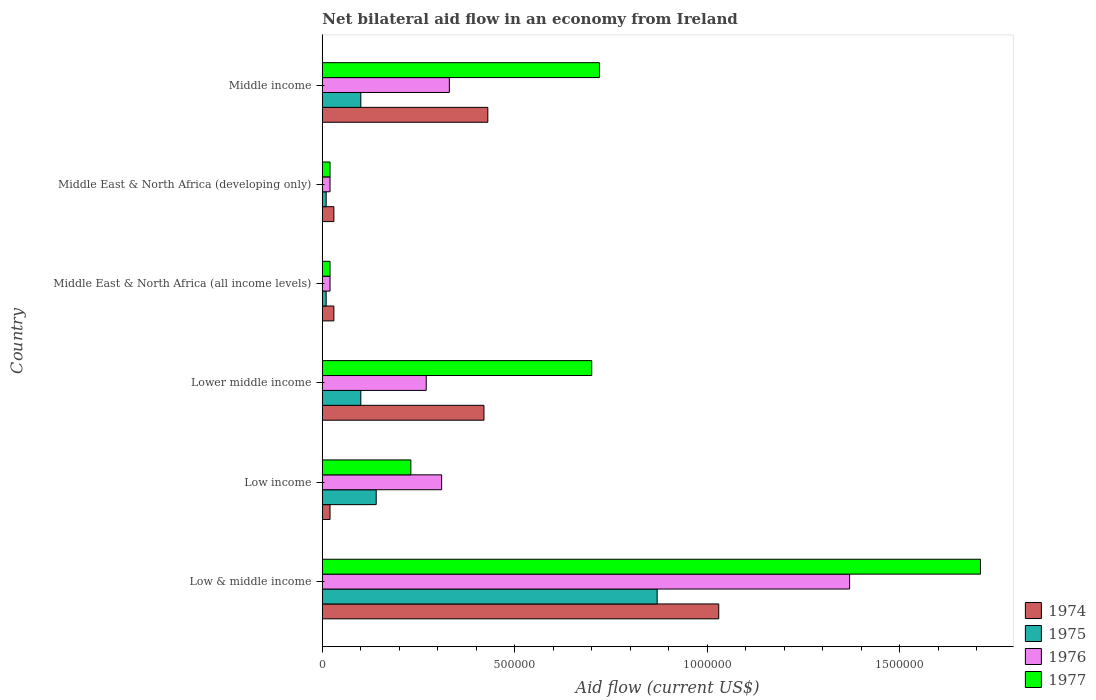How many groups of bars are there?
Offer a very short reply. 6. Are the number of bars on each tick of the Y-axis equal?
Keep it short and to the point. Yes. How many bars are there on the 2nd tick from the top?
Offer a very short reply. 4. How many bars are there on the 6th tick from the bottom?
Ensure brevity in your answer.  4. In how many cases, is the number of bars for a given country not equal to the number of legend labels?
Make the answer very short. 0. What is the net bilateral aid flow in 1977 in Middle East & North Africa (developing only)?
Your answer should be very brief. 2.00e+04. Across all countries, what is the maximum net bilateral aid flow in 1975?
Offer a very short reply. 8.70e+05. In which country was the net bilateral aid flow in 1976 minimum?
Ensure brevity in your answer.  Middle East & North Africa (all income levels). What is the total net bilateral aid flow in 1976 in the graph?
Keep it short and to the point. 2.32e+06. What is the difference between the net bilateral aid flow in 1977 in Low income and that in Middle income?
Your response must be concise. -4.90e+05. What is the difference between the net bilateral aid flow in 1977 in Middle East & North Africa (all income levels) and the net bilateral aid flow in 1975 in Low income?
Your response must be concise. -1.20e+05. What is the average net bilateral aid flow in 1974 per country?
Offer a very short reply. 3.27e+05. What is the difference between the net bilateral aid flow in 1976 and net bilateral aid flow in 1974 in Middle East & North Africa (developing only)?
Offer a very short reply. -10000. In how many countries, is the net bilateral aid flow in 1975 greater than 300000 US$?
Give a very brief answer. 1. What is the ratio of the net bilateral aid flow in 1974 in Lower middle income to that in Middle income?
Offer a very short reply. 0.98. Is the difference between the net bilateral aid flow in 1976 in Middle East & North Africa (all income levels) and Middle East & North Africa (developing only) greater than the difference between the net bilateral aid flow in 1974 in Middle East & North Africa (all income levels) and Middle East & North Africa (developing only)?
Offer a very short reply. No. What is the difference between the highest and the lowest net bilateral aid flow in 1975?
Offer a terse response. 8.60e+05. In how many countries, is the net bilateral aid flow in 1977 greater than the average net bilateral aid flow in 1977 taken over all countries?
Keep it short and to the point. 3. Is it the case that in every country, the sum of the net bilateral aid flow in 1975 and net bilateral aid flow in 1977 is greater than the sum of net bilateral aid flow in 1976 and net bilateral aid flow in 1974?
Give a very brief answer. No. What does the 1st bar from the top in Lower middle income represents?
Give a very brief answer. 1977. What does the 1st bar from the bottom in Low & middle income represents?
Provide a short and direct response. 1974. Is it the case that in every country, the sum of the net bilateral aid flow in 1976 and net bilateral aid flow in 1974 is greater than the net bilateral aid flow in 1977?
Your answer should be very brief. No. How many bars are there?
Offer a very short reply. 24. Are all the bars in the graph horizontal?
Provide a succinct answer. Yes. Does the graph contain any zero values?
Your answer should be very brief. No. Does the graph contain grids?
Offer a terse response. No. How many legend labels are there?
Your answer should be very brief. 4. What is the title of the graph?
Your answer should be very brief. Net bilateral aid flow in an economy from Ireland. What is the label or title of the X-axis?
Your answer should be compact. Aid flow (current US$). What is the Aid flow (current US$) of 1974 in Low & middle income?
Offer a terse response. 1.03e+06. What is the Aid flow (current US$) of 1975 in Low & middle income?
Offer a terse response. 8.70e+05. What is the Aid flow (current US$) of 1976 in Low & middle income?
Your answer should be very brief. 1.37e+06. What is the Aid flow (current US$) of 1977 in Low & middle income?
Keep it short and to the point. 1.71e+06. What is the Aid flow (current US$) of 1976 in Low income?
Your response must be concise. 3.10e+05. What is the Aid flow (current US$) in 1974 in Lower middle income?
Give a very brief answer. 4.20e+05. What is the Aid flow (current US$) of 1975 in Lower middle income?
Your answer should be very brief. 1.00e+05. What is the Aid flow (current US$) in 1976 in Lower middle income?
Make the answer very short. 2.70e+05. What is the Aid flow (current US$) of 1977 in Lower middle income?
Your answer should be very brief. 7.00e+05. What is the Aid flow (current US$) in 1976 in Middle East & North Africa (all income levels)?
Offer a very short reply. 2.00e+04. What is the Aid flow (current US$) of 1977 in Middle East & North Africa (all income levels)?
Provide a succinct answer. 2.00e+04. What is the Aid flow (current US$) in 1976 in Middle income?
Your response must be concise. 3.30e+05. What is the Aid flow (current US$) of 1977 in Middle income?
Give a very brief answer. 7.20e+05. Across all countries, what is the maximum Aid flow (current US$) of 1974?
Your answer should be very brief. 1.03e+06. Across all countries, what is the maximum Aid flow (current US$) of 1975?
Provide a succinct answer. 8.70e+05. Across all countries, what is the maximum Aid flow (current US$) in 1976?
Your answer should be very brief. 1.37e+06. Across all countries, what is the maximum Aid flow (current US$) of 1977?
Provide a short and direct response. 1.71e+06. Across all countries, what is the minimum Aid flow (current US$) in 1974?
Your response must be concise. 2.00e+04. Across all countries, what is the minimum Aid flow (current US$) in 1976?
Make the answer very short. 2.00e+04. Across all countries, what is the minimum Aid flow (current US$) in 1977?
Provide a succinct answer. 2.00e+04. What is the total Aid flow (current US$) of 1974 in the graph?
Offer a very short reply. 1.96e+06. What is the total Aid flow (current US$) of 1975 in the graph?
Your answer should be compact. 1.23e+06. What is the total Aid flow (current US$) of 1976 in the graph?
Your answer should be very brief. 2.32e+06. What is the total Aid flow (current US$) of 1977 in the graph?
Your response must be concise. 3.40e+06. What is the difference between the Aid flow (current US$) of 1974 in Low & middle income and that in Low income?
Provide a short and direct response. 1.01e+06. What is the difference between the Aid flow (current US$) of 1975 in Low & middle income and that in Low income?
Provide a short and direct response. 7.30e+05. What is the difference between the Aid flow (current US$) in 1976 in Low & middle income and that in Low income?
Provide a short and direct response. 1.06e+06. What is the difference between the Aid flow (current US$) of 1977 in Low & middle income and that in Low income?
Give a very brief answer. 1.48e+06. What is the difference between the Aid flow (current US$) in 1974 in Low & middle income and that in Lower middle income?
Keep it short and to the point. 6.10e+05. What is the difference between the Aid flow (current US$) in 1975 in Low & middle income and that in Lower middle income?
Give a very brief answer. 7.70e+05. What is the difference between the Aid flow (current US$) in 1976 in Low & middle income and that in Lower middle income?
Provide a short and direct response. 1.10e+06. What is the difference between the Aid flow (current US$) of 1977 in Low & middle income and that in Lower middle income?
Your answer should be compact. 1.01e+06. What is the difference between the Aid flow (current US$) of 1974 in Low & middle income and that in Middle East & North Africa (all income levels)?
Give a very brief answer. 1.00e+06. What is the difference between the Aid flow (current US$) of 1975 in Low & middle income and that in Middle East & North Africa (all income levels)?
Provide a succinct answer. 8.60e+05. What is the difference between the Aid flow (current US$) in 1976 in Low & middle income and that in Middle East & North Africa (all income levels)?
Make the answer very short. 1.35e+06. What is the difference between the Aid flow (current US$) of 1977 in Low & middle income and that in Middle East & North Africa (all income levels)?
Your answer should be compact. 1.69e+06. What is the difference between the Aid flow (current US$) in 1975 in Low & middle income and that in Middle East & North Africa (developing only)?
Provide a succinct answer. 8.60e+05. What is the difference between the Aid flow (current US$) of 1976 in Low & middle income and that in Middle East & North Africa (developing only)?
Make the answer very short. 1.35e+06. What is the difference between the Aid flow (current US$) in 1977 in Low & middle income and that in Middle East & North Africa (developing only)?
Your answer should be compact. 1.69e+06. What is the difference between the Aid flow (current US$) of 1975 in Low & middle income and that in Middle income?
Give a very brief answer. 7.70e+05. What is the difference between the Aid flow (current US$) of 1976 in Low & middle income and that in Middle income?
Your answer should be very brief. 1.04e+06. What is the difference between the Aid flow (current US$) of 1977 in Low & middle income and that in Middle income?
Provide a succinct answer. 9.90e+05. What is the difference between the Aid flow (current US$) in 1974 in Low income and that in Lower middle income?
Your answer should be very brief. -4.00e+05. What is the difference between the Aid flow (current US$) in 1977 in Low income and that in Lower middle income?
Ensure brevity in your answer.  -4.70e+05. What is the difference between the Aid flow (current US$) of 1974 in Low income and that in Middle East & North Africa (all income levels)?
Your answer should be very brief. -10000. What is the difference between the Aid flow (current US$) in 1975 in Low income and that in Middle East & North Africa (all income levels)?
Ensure brevity in your answer.  1.30e+05. What is the difference between the Aid flow (current US$) of 1976 in Low income and that in Middle East & North Africa (developing only)?
Your response must be concise. 2.90e+05. What is the difference between the Aid flow (current US$) of 1977 in Low income and that in Middle East & North Africa (developing only)?
Make the answer very short. 2.10e+05. What is the difference between the Aid flow (current US$) of 1974 in Low income and that in Middle income?
Give a very brief answer. -4.10e+05. What is the difference between the Aid flow (current US$) of 1977 in Low income and that in Middle income?
Your answer should be very brief. -4.90e+05. What is the difference between the Aid flow (current US$) of 1974 in Lower middle income and that in Middle East & North Africa (all income levels)?
Provide a short and direct response. 3.90e+05. What is the difference between the Aid flow (current US$) in 1975 in Lower middle income and that in Middle East & North Africa (all income levels)?
Your answer should be very brief. 9.00e+04. What is the difference between the Aid flow (current US$) in 1977 in Lower middle income and that in Middle East & North Africa (all income levels)?
Keep it short and to the point. 6.80e+05. What is the difference between the Aid flow (current US$) in 1974 in Lower middle income and that in Middle East & North Africa (developing only)?
Offer a very short reply. 3.90e+05. What is the difference between the Aid flow (current US$) of 1975 in Lower middle income and that in Middle East & North Africa (developing only)?
Provide a short and direct response. 9.00e+04. What is the difference between the Aid flow (current US$) of 1977 in Lower middle income and that in Middle East & North Africa (developing only)?
Ensure brevity in your answer.  6.80e+05. What is the difference between the Aid flow (current US$) in 1975 in Lower middle income and that in Middle income?
Give a very brief answer. 0. What is the difference between the Aid flow (current US$) in 1976 in Lower middle income and that in Middle income?
Offer a very short reply. -6.00e+04. What is the difference between the Aid flow (current US$) of 1977 in Lower middle income and that in Middle income?
Your answer should be very brief. -2.00e+04. What is the difference between the Aid flow (current US$) of 1974 in Middle East & North Africa (all income levels) and that in Middle East & North Africa (developing only)?
Your response must be concise. 0. What is the difference between the Aid flow (current US$) of 1976 in Middle East & North Africa (all income levels) and that in Middle East & North Africa (developing only)?
Provide a succinct answer. 0. What is the difference between the Aid flow (current US$) of 1974 in Middle East & North Africa (all income levels) and that in Middle income?
Your answer should be very brief. -4.00e+05. What is the difference between the Aid flow (current US$) in 1976 in Middle East & North Africa (all income levels) and that in Middle income?
Offer a terse response. -3.10e+05. What is the difference between the Aid flow (current US$) of 1977 in Middle East & North Africa (all income levels) and that in Middle income?
Make the answer very short. -7.00e+05. What is the difference between the Aid flow (current US$) in 1974 in Middle East & North Africa (developing only) and that in Middle income?
Ensure brevity in your answer.  -4.00e+05. What is the difference between the Aid flow (current US$) in 1976 in Middle East & North Africa (developing only) and that in Middle income?
Provide a succinct answer. -3.10e+05. What is the difference between the Aid flow (current US$) of 1977 in Middle East & North Africa (developing only) and that in Middle income?
Your answer should be compact. -7.00e+05. What is the difference between the Aid flow (current US$) of 1974 in Low & middle income and the Aid flow (current US$) of 1975 in Low income?
Provide a short and direct response. 8.90e+05. What is the difference between the Aid flow (current US$) in 1974 in Low & middle income and the Aid flow (current US$) in 1976 in Low income?
Keep it short and to the point. 7.20e+05. What is the difference between the Aid flow (current US$) of 1975 in Low & middle income and the Aid flow (current US$) of 1976 in Low income?
Offer a terse response. 5.60e+05. What is the difference between the Aid flow (current US$) in 1975 in Low & middle income and the Aid flow (current US$) in 1977 in Low income?
Provide a short and direct response. 6.40e+05. What is the difference between the Aid flow (current US$) in 1976 in Low & middle income and the Aid flow (current US$) in 1977 in Low income?
Keep it short and to the point. 1.14e+06. What is the difference between the Aid flow (current US$) of 1974 in Low & middle income and the Aid flow (current US$) of 1975 in Lower middle income?
Give a very brief answer. 9.30e+05. What is the difference between the Aid flow (current US$) of 1974 in Low & middle income and the Aid flow (current US$) of 1976 in Lower middle income?
Give a very brief answer. 7.60e+05. What is the difference between the Aid flow (current US$) in 1976 in Low & middle income and the Aid flow (current US$) in 1977 in Lower middle income?
Make the answer very short. 6.70e+05. What is the difference between the Aid flow (current US$) of 1974 in Low & middle income and the Aid flow (current US$) of 1975 in Middle East & North Africa (all income levels)?
Provide a short and direct response. 1.02e+06. What is the difference between the Aid flow (current US$) in 1974 in Low & middle income and the Aid flow (current US$) in 1976 in Middle East & North Africa (all income levels)?
Provide a succinct answer. 1.01e+06. What is the difference between the Aid flow (current US$) in 1974 in Low & middle income and the Aid flow (current US$) in 1977 in Middle East & North Africa (all income levels)?
Your answer should be very brief. 1.01e+06. What is the difference between the Aid flow (current US$) in 1975 in Low & middle income and the Aid flow (current US$) in 1976 in Middle East & North Africa (all income levels)?
Keep it short and to the point. 8.50e+05. What is the difference between the Aid flow (current US$) of 1975 in Low & middle income and the Aid flow (current US$) of 1977 in Middle East & North Africa (all income levels)?
Make the answer very short. 8.50e+05. What is the difference between the Aid flow (current US$) of 1976 in Low & middle income and the Aid flow (current US$) of 1977 in Middle East & North Africa (all income levels)?
Keep it short and to the point. 1.35e+06. What is the difference between the Aid flow (current US$) of 1974 in Low & middle income and the Aid flow (current US$) of 1975 in Middle East & North Africa (developing only)?
Provide a succinct answer. 1.02e+06. What is the difference between the Aid flow (current US$) in 1974 in Low & middle income and the Aid flow (current US$) in 1976 in Middle East & North Africa (developing only)?
Offer a terse response. 1.01e+06. What is the difference between the Aid flow (current US$) of 1974 in Low & middle income and the Aid flow (current US$) of 1977 in Middle East & North Africa (developing only)?
Keep it short and to the point. 1.01e+06. What is the difference between the Aid flow (current US$) in 1975 in Low & middle income and the Aid flow (current US$) in 1976 in Middle East & North Africa (developing only)?
Make the answer very short. 8.50e+05. What is the difference between the Aid flow (current US$) in 1975 in Low & middle income and the Aid flow (current US$) in 1977 in Middle East & North Africa (developing only)?
Make the answer very short. 8.50e+05. What is the difference between the Aid flow (current US$) in 1976 in Low & middle income and the Aid flow (current US$) in 1977 in Middle East & North Africa (developing only)?
Keep it short and to the point. 1.35e+06. What is the difference between the Aid flow (current US$) in 1974 in Low & middle income and the Aid flow (current US$) in 1975 in Middle income?
Make the answer very short. 9.30e+05. What is the difference between the Aid flow (current US$) in 1975 in Low & middle income and the Aid flow (current US$) in 1976 in Middle income?
Ensure brevity in your answer.  5.40e+05. What is the difference between the Aid flow (current US$) in 1975 in Low & middle income and the Aid flow (current US$) in 1977 in Middle income?
Give a very brief answer. 1.50e+05. What is the difference between the Aid flow (current US$) in 1976 in Low & middle income and the Aid flow (current US$) in 1977 in Middle income?
Your response must be concise. 6.50e+05. What is the difference between the Aid flow (current US$) in 1974 in Low income and the Aid flow (current US$) in 1975 in Lower middle income?
Provide a succinct answer. -8.00e+04. What is the difference between the Aid flow (current US$) in 1974 in Low income and the Aid flow (current US$) in 1976 in Lower middle income?
Offer a terse response. -2.50e+05. What is the difference between the Aid flow (current US$) of 1974 in Low income and the Aid flow (current US$) of 1977 in Lower middle income?
Your answer should be compact. -6.80e+05. What is the difference between the Aid flow (current US$) in 1975 in Low income and the Aid flow (current US$) in 1977 in Lower middle income?
Keep it short and to the point. -5.60e+05. What is the difference between the Aid flow (current US$) in 1976 in Low income and the Aid flow (current US$) in 1977 in Lower middle income?
Provide a short and direct response. -3.90e+05. What is the difference between the Aid flow (current US$) of 1974 in Low income and the Aid flow (current US$) of 1975 in Middle East & North Africa (all income levels)?
Offer a terse response. 10000. What is the difference between the Aid flow (current US$) in 1974 in Low income and the Aid flow (current US$) in 1976 in Middle East & North Africa (all income levels)?
Provide a short and direct response. 0. What is the difference between the Aid flow (current US$) of 1974 in Low income and the Aid flow (current US$) of 1977 in Middle East & North Africa (all income levels)?
Provide a succinct answer. 0. What is the difference between the Aid flow (current US$) in 1974 in Low income and the Aid flow (current US$) in 1977 in Middle East & North Africa (developing only)?
Keep it short and to the point. 0. What is the difference between the Aid flow (current US$) of 1975 in Low income and the Aid flow (current US$) of 1976 in Middle East & North Africa (developing only)?
Keep it short and to the point. 1.20e+05. What is the difference between the Aid flow (current US$) of 1974 in Low income and the Aid flow (current US$) of 1975 in Middle income?
Provide a succinct answer. -8.00e+04. What is the difference between the Aid flow (current US$) in 1974 in Low income and the Aid flow (current US$) in 1976 in Middle income?
Offer a terse response. -3.10e+05. What is the difference between the Aid flow (current US$) in 1974 in Low income and the Aid flow (current US$) in 1977 in Middle income?
Ensure brevity in your answer.  -7.00e+05. What is the difference between the Aid flow (current US$) in 1975 in Low income and the Aid flow (current US$) in 1976 in Middle income?
Your response must be concise. -1.90e+05. What is the difference between the Aid flow (current US$) of 1975 in Low income and the Aid flow (current US$) of 1977 in Middle income?
Give a very brief answer. -5.80e+05. What is the difference between the Aid flow (current US$) in 1976 in Low income and the Aid flow (current US$) in 1977 in Middle income?
Offer a very short reply. -4.10e+05. What is the difference between the Aid flow (current US$) of 1975 in Lower middle income and the Aid flow (current US$) of 1976 in Middle East & North Africa (all income levels)?
Your response must be concise. 8.00e+04. What is the difference between the Aid flow (current US$) of 1976 in Lower middle income and the Aid flow (current US$) of 1977 in Middle East & North Africa (all income levels)?
Your answer should be very brief. 2.50e+05. What is the difference between the Aid flow (current US$) of 1974 in Lower middle income and the Aid flow (current US$) of 1977 in Middle East & North Africa (developing only)?
Your response must be concise. 4.00e+05. What is the difference between the Aid flow (current US$) of 1974 in Lower middle income and the Aid flow (current US$) of 1975 in Middle income?
Ensure brevity in your answer.  3.20e+05. What is the difference between the Aid flow (current US$) in 1974 in Lower middle income and the Aid flow (current US$) in 1976 in Middle income?
Provide a succinct answer. 9.00e+04. What is the difference between the Aid flow (current US$) of 1974 in Lower middle income and the Aid flow (current US$) of 1977 in Middle income?
Provide a succinct answer. -3.00e+05. What is the difference between the Aid flow (current US$) of 1975 in Lower middle income and the Aid flow (current US$) of 1976 in Middle income?
Offer a terse response. -2.30e+05. What is the difference between the Aid flow (current US$) in 1975 in Lower middle income and the Aid flow (current US$) in 1977 in Middle income?
Give a very brief answer. -6.20e+05. What is the difference between the Aid flow (current US$) in 1976 in Lower middle income and the Aid flow (current US$) in 1977 in Middle income?
Offer a terse response. -4.50e+05. What is the difference between the Aid flow (current US$) of 1974 in Middle East & North Africa (all income levels) and the Aid flow (current US$) of 1975 in Middle East & North Africa (developing only)?
Your answer should be compact. 2.00e+04. What is the difference between the Aid flow (current US$) of 1974 in Middle East & North Africa (all income levels) and the Aid flow (current US$) of 1976 in Middle East & North Africa (developing only)?
Provide a succinct answer. 10000. What is the difference between the Aid flow (current US$) in 1975 in Middle East & North Africa (all income levels) and the Aid flow (current US$) in 1977 in Middle East & North Africa (developing only)?
Offer a very short reply. -10000. What is the difference between the Aid flow (current US$) of 1974 in Middle East & North Africa (all income levels) and the Aid flow (current US$) of 1977 in Middle income?
Your answer should be very brief. -6.90e+05. What is the difference between the Aid flow (current US$) of 1975 in Middle East & North Africa (all income levels) and the Aid flow (current US$) of 1976 in Middle income?
Give a very brief answer. -3.20e+05. What is the difference between the Aid flow (current US$) of 1975 in Middle East & North Africa (all income levels) and the Aid flow (current US$) of 1977 in Middle income?
Provide a succinct answer. -7.10e+05. What is the difference between the Aid flow (current US$) of 1976 in Middle East & North Africa (all income levels) and the Aid flow (current US$) of 1977 in Middle income?
Provide a succinct answer. -7.00e+05. What is the difference between the Aid flow (current US$) in 1974 in Middle East & North Africa (developing only) and the Aid flow (current US$) in 1976 in Middle income?
Provide a short and direct response. -3.00e+05. What is the difference between the Aid flow (current US$) in 1974 in Middle East & North Africa (developing only) and the Aid flow (current US$) in 1977 in Middle income?
Give a very brief answer. -6.90e+05. What is the difference between the Aid flow (current US$) of 1975 in Middle East & North Africa (developing only) and the Aid flow (current US$) of 1976 in Middle income?
Keep it short and to the point. -3.20e+05. What is the difference between the Aid flow (current US$) of 1975 in Middle East & North Africa (developing only) and the Aid flow (current US$) of 1977 in Middle income?
Your answer should be very brief. -7.10e+05. What is the difference between the Aid flow (current US$) in 1976 in Middle East & North Africa (developing only) and the Aid flow (current US$) in 1977 in Middle income?
Give a very brief answer. -7.00e+05. What is the average Aid flow (current US$) in 1974 per country?
Give a very brief answer. 3.27e+05. What is the average Aid flow (current US$) in 1975 per country?
Make the answer very short. 2.05e+05. What is the average Aid flow (current US$) in 1976 per country?
Provide a short and direct response. 3.87e+05. What is the average Aid flow (current US$) of 1977 per country?
Provide a succinct answer. 5.67e+05. What is the difference between the Aid flow (current US$) in 1974 and Aid flow (current US$) in 1977 in Low & middle income?
Your answer should be compact. -6.80e+05. What is the difference between the Aid flow (current US$) in 1975 and Aid flow (current US$) in 1976 in Low & middle income?
Your response must be concise. -5.00e+05. What is the difference between the Aid flow (current US$) in 1975 and Aid flow (current US$) in 1977 in Low & middle income?
Offer a very short reply. -8.40e+05. What is the difference between the Aid flow (current US$) in 1975 and Aid flow (current US$) in 1977 in Low income?
Keep it short and to the point. -9.00e+04. What is the difference between the Aid flow (current US$) of 1974 and Aid flow (current US$) of 1975 in Lower middle income?
Keep it short and to the point. 3.20e+05. What is the difference between the Aid flow (current US$) of 1974 and Aid flow (current US$) of 1977 in Lower middle income?
Provide a short and direct response. -2.80e+05. What is the difference between the Aid flow (current US$) in 1975 and Aid flow (current US$) in 1977 in Lower middle income?
Offer a very short reply. -6.00e+05. What is the difference between the Aid flow (current US$) of 1976 and Aid flow (current US$) of 1977 in Lower middle income?
Offer a terse response. -4.30e+05. What is the difference between the Aid flow (current US$) in 1974 and Aid flow (current US$) in 1977 in Middle East & North Africa (all income levels)?
Make the answer very short. 10000. What is the difference between the Aid flow (current US$) of 1975 and Aid flow (current US$) of 1976 in Middle East & North Africa (all income levels)?
Ensure brevity in your answer.  -10000. What is the difference between the Aid flow (current US$) in 1974 and Aid flow (current US$) in 1975 in Middle East & North Africa (developing only)?
Give a very brief answer. 2.00e+04. What is the difference between the Aid flow (current US$) of 1974 and Aid flow (current US$) of 1976 in Middle East & North Africa (developing only)?
Ensure brevity in your answer.  10000. What is the difference between the Aid flow (current US$) of 1974 and Aid flow (current US$) of 1977 in Middle East & North Africa (developing only)?
Your response must be concise. 10000. What is the difference between the Aid flow (current US$) of 1975 and Aid flow (current US$) of 1976 in Middle East & North Africa (developing only)?
Make the answer very short. -10000. What is the difference between the Aid flow (current US$) of 1975 and Aid flow (current US$) of 1977 in Middle East & North Africa (developing only)?
Give a very brief answer. -10000. What is the difference between the Aid flow (current US$) in 1974 and Aid flow (current US$) in 1975 in Middle income?
Provide a short and direct response. 3.30e+05. What is the difference between the Aid flow (current US$) in 1975 and Aid flow (current US$) in 1977 in Middle income?
Offer a very short reply. -6.20e+05. What is the difference between the Aid flow (current US$) of 1976 and Aid flow (current US$) of 1977 in Middle income?
Ensure brevity in your answer.  -3.90e+05. What is the ratio of the Aid flow (current US$) in 1974 in Low & middle income to that in Low income?
Keep it short and to the point. 51.5. What is the ratio of the Aid flow (current US$) of 1975 in Low & middle income to that in Low income?
Offer a terse response. 6.21. What is the ratio of the Aid flow (current US$) in 1976 in Low & middle income to that in Low income?
Make the answer very short. 4.42. What is the ratio of the Aid flow (current US$) of 1977 in Low & middle income to that in Low income?
Offer a terse response. 7.43. What is the ratio of the Aid flow (current US$) in 1974 in Low & middle income to that in Lower middle income?
Make the answer very short. 2.45. What is the ratio of the Aid flow (current US$) of 1975 in Low & middle income to that in Lower middle income?
Provide a short and direct response. 8.7. What is the ratio of the Aid flow (current US$) in 1976 in Low & middle income to that in Lower middle income?
Your answer should be very brief. 5.07. What is the ratio of the Aid flow (current US$) of 1977 in Low & middle income to that in Lower middle income?
Offer a very short reply. 2.44. What is the ratio of the Aid flow (current US$) of 1974 in Low & middle income to that in Middle East & North Africa (all income levels)?
Provide a short and direct response. 34.33. What is the ratio of the Aid flow (current US$) of 1976 in Low & middle income to that in Middle East & North Africa (all income levels)?
Your response must be concise. 68.5. What is the ratio of the Aid flow (current US$) in 1977 in Low & middle income to that in Middle East & North Africa (all income levels)?
Provide a short and direct response. 85.5. What is the ratio of the Aid flow (current US$) of 1974 in Low & middle income to that in Middle East & North Africa (developing only)?
Your answer should be compact. 34.33. What is the ratio of the Aid flow (current US$) of 1975 in Low & middle income to that in Middle East & North Africa (developing only)?
Your answer should be compact. 87. What is the ratio of the Aid flow (current US$) of 1976 in Low & middle income to that in Middle East & North Africa (developing only)?
Give a very brief answer. 68.5. What is the ratio of the Aid flow (current US$) of 1977 in Low & middle income to that in Middle East & North Africa (developing only)?
Provide a short and direct response. 85.5. What is the ratio of the Aid flow (current US$) of 1974 in Low & middle income to that in Middle income?
Your response must be concise. 2.4. What is the ratio of the Aid flow (current US$) in 1975 in Low & middle income to that in Middle income?
Make the answer very short. 8.7. What is the ratio of the Aid flow (current US$) in 1976 in Low & middle income to that in Middle income?
Your answer should be very brief. 4.15. What is the ratio of the Aid flow (current US$) of 1977 in Low & middle income to that in Middle income?
Your answer should be very brief. 2.38. What is the ratio of the Aid flow (current US$) in 1974 in Low income to that in Lower middle income?
Your answer should be compact. 0.05. What is the ratio of the Aid flow (current US$) of 1976 in Low income to that in Lower middle income?
Ensure brevity in your answer.  1.15. What is the ratio of the Aid flow (current US$) of 1977 in Low income to that in Lower middle income?
Make the answer very short. 0.33. What is the ratio of the Aid flow (current US$) in 1974 in Low income to that in Middle East & North Africa (all income levels)?
Your answer should be compact. 0.67. What is the ratio of the Aid flow (current US$) in 1977 in Low income to that in Middle East & North Africa (all income levels)?
Keep it short and to the point. 11.5. What is the ratio of the Aid flow (current US$) in 1975 in Low income to that in Middle East & North Africa (developing only)?
Your answer should be compact. 14. What is the ratio of the Aid flow (current US$) in 1976 in Low income to that in Middle East & North Africa (developing only)?
Your answer should be compact. 15.5. What is the ratio of the Aid flow (current US$) in 1977 in Low income to that in Middle East & North Africa (developing only)?
Make the answer very short. 11.5. What is the ratio of the Aid flow (current US$) of 1974 in Low income to that in Middle income?
Make the answer very short. 0.05. What is the ratio of the Aid flow (current US$) of 1976 in Low income to that in Middle income?
Give a very brief answer. 0.94. What is the ratio of the Aid flow (current US$) in 1977 in Low income to that in Middle income?
Offer a terse response. 0.32. What is the ratio of the Aid flow (current US$) in 1975 in Lower middle income to that in Middle East & North Africa (all income levels)?
Your response must be concise. 10. What is the ratio of the Aid flow (current US$) in 1976 in Lower middle income to that in Middle East & North Africa (all income levels)?
Your answer should be very brief. 13.5. What is the ratio of the Aid flow (current US$) of 1977 in Lower middle income to that in Middle East & North Africa (all income levels)?
Offer a terse response. 35. What is the ratio of the Aid flow (current US$) in 1976 in Lower middle income to that in Middle East & North Africa (developing only)?
Provide a short and direct response. 13.5. What is the ratio of the Aid flow (current US$) in 1977 in Lower middle income to that in Middle East & North Africa (developing only)?
Your answer should be compact. 35. What is the ratio of the Aid flow (current US$) in 1974 in Lower middle income to that in Middle income?
Keep it short and to the point. 0.98. What is the ratio of the Aid flow (current US$) in 1975 in Lower middle income to that in Middle income?
Offer a terse response. 1. What is the ratio of the Aid flow (current US$) of 1976 in Lower middle income to that in Middle income?
Offer a terse response. 0.82. What is the ratio of the Aid flow (current US$) of 1977 in Lower middle income to that in Middle income?
Your response must be concise. 0.97. What is the ratio of the Aid flow (current US$) in 1976 in Middle East & North Africa (all income levels) to that in Middle East & North Africa (developing only)?
Make the answer very short. 1. What is the ratio of the Aid flow (current US$) of 1977 in Middle East & North Africa (all income levels) to that in Middle East & North Africa (developing only)?
Provide a short and direct response. 1. What is the ratio of the Aid flow (current US$) of 1974 in Middle East & North Africa (all income levels) to that in Middle income?
Provide a short and direct response. 0.07. What is the ratio of the Aid flow (current US$) in 1975 in Middle East & North Africa (all income levels) to that in Middle income?
Give a very brief answer. 0.1. What is the ratio of the Aid flow (current US$) in 1976 in Middle East & North Africa (all income levels) to that in Middle income?
Keep it short and to the point. 0.06. What is the ratio of the Aid flow (current US$) in 1977 in Middle East & North Africa (all income levels) to that in Middle income?
Give a very brief answer. 0.03. What is the ratio of the Aid flow (current US$) of 1974 in Middle East & North Africa (developing only) to that in Middle income?
Your answer should be very brief. 0.07. What is the ratio of the Aid flow (current US$) of 1975 in Middle East & North Africa (developing only) to that in Middle income?
Your answer should be very brief. 0.1. What is the ratio of the Aid flow (current US$) of 1976 in Middle East & North Africa (developing only) to that in Middle income?
Offer a terse response. 0.06. What is the ratio of the Aid flow (current US$) of 1977 in Middle East & North Africa (developing only) to that in Middle income?
Provide a succinct answer. 0.03. What is the difference between the highest and the second highest Aid flow (current US$) in 1975?
Offer a very short reply. 7.30e+05. What is the difference between the highest and the second highest Aid flow (current US$) in 1976?
Keep it short and to the point. 1.04e+06. What is the difference between the highest and the second highest Aid flow (current US$) in 1977?
Your answer should be compact. 9.90e+05. What is the difference between the highest and the lowest Aid flow (current US$) in 1974?
Keep it short and to the point. 1.01e+06. What is the difference between the highest and the lowest Aid flow (current US$) of 1975?
Provide a short and direct response. 8.60e+05. What is the difference between the highest and the lowest Aid flow (current US$) of 1976?
Your response must be concise. 1.35e+06. What is the difference between the highest and the lowest Aid flow (current US$) of 1977?
Offer a very short reply. 1.69e+06. 